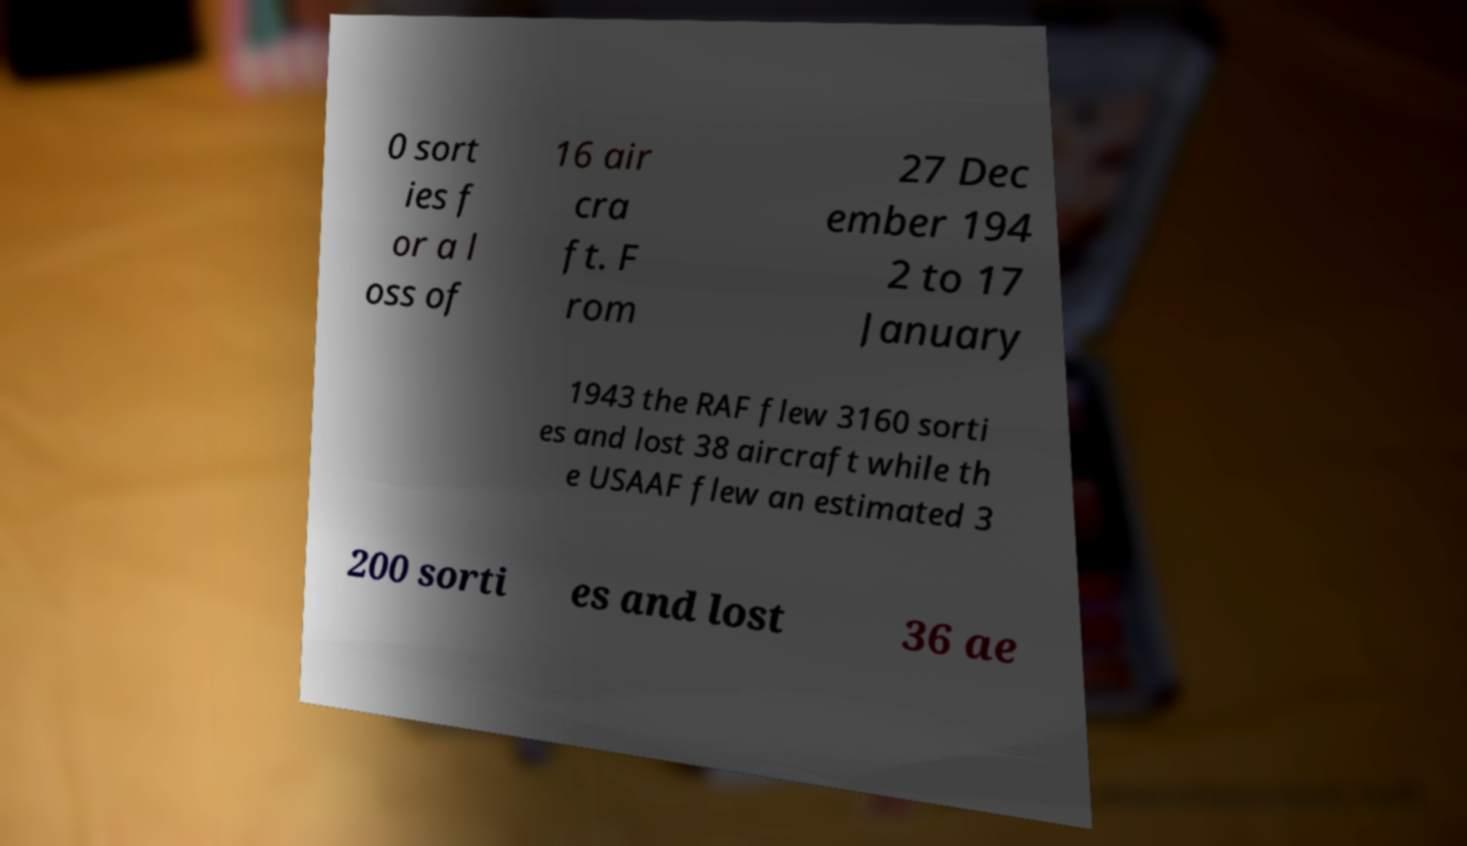Could you extract and type out the text from this image? 0 sort ies f or a l oss of 16 air cra ft. F rom 27 Dec ember 194 2 to 17 January 1943 the RAF flew 3160 sorti es and lost 38 aircraft while th e USAAF flew an estimated 3 200 sorti es and lost 36 ae 